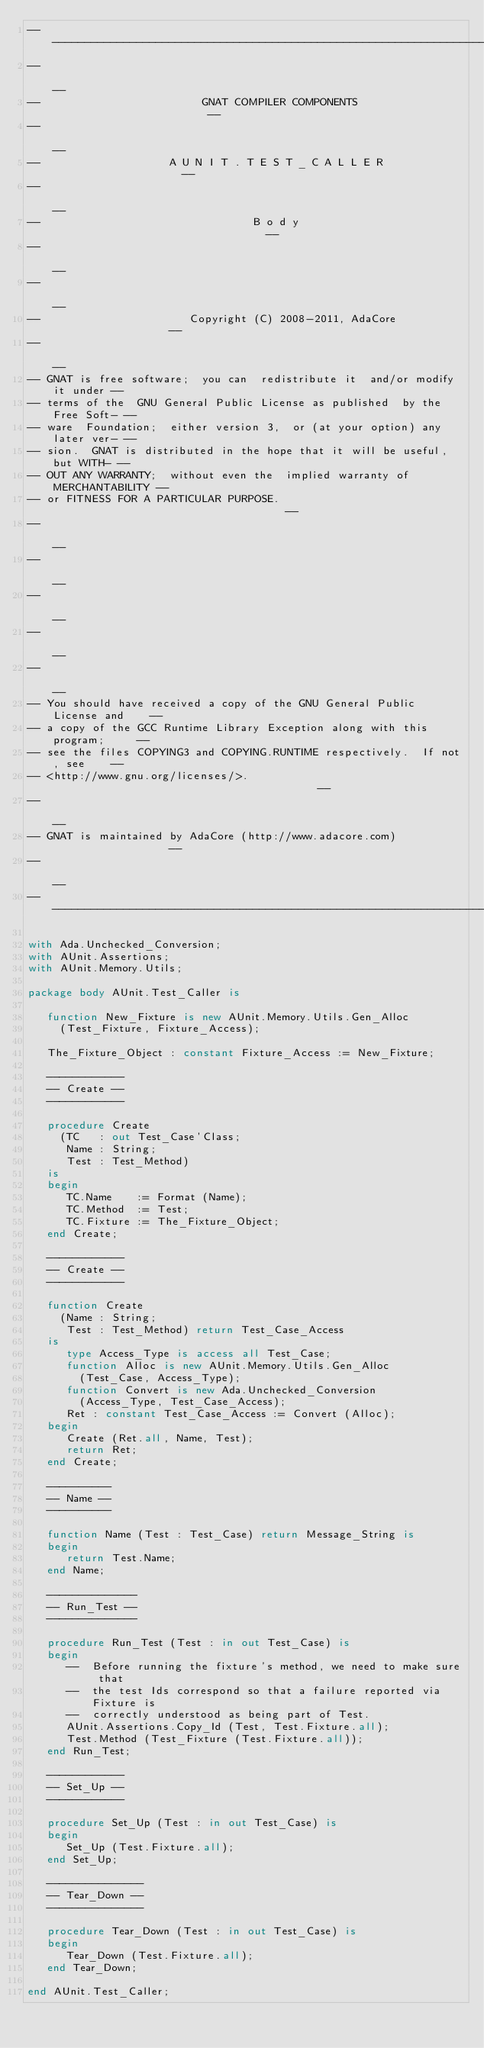Convert code to text. <code><loc_0><loc_0><loc_500><loc_500><_Ada_>------------------------------------------------------------------------------
--                                                                          --
--                         GNAT COMPILER COMPONENTS                         --
--                                                                          --
--                    A U N I T . T E S T _ C A L L E R                     --
--                                                                          --
--                                 B o d y                                  --
--                                                                          --
--                                                                          --
--                       Copyright (C) 2008-2011, AdaCore                   --
--                                                                          --
-- GNAT is free software;  you can  redistribute it  and/or modify it under --
-- terms of the  GNU General Public License as published  by the Free Soft- --
-- ware  Foundation;  either version 3,  or (at your option) any later ver- --
-- sion.  GNAT is distributed in the hope that it will be useful, but WITH- --
-- OUT ANY WARRANTY;  without even the  implied warranty of MERCHANTABILITY --
-- or FITNESS FOR A PARTICULAR PURPOSE.                                     --
--                                                                          --
--                                                                          --
--                                                                          --
--                                                                          --
--                                                                          --
-- You should have received a copy of the GNU General Public License and    --
-- a copy of the GCC Runtime Library Exception along with this program;     --
-- see the files COPYING3 and COPYING.RUNTIME respectively.  If not, see    --
-- <http://www.gnu.org/licenses/>.                                          --
--                                                                          --
-- GNAT is maintained by AdaCore (http://www.adacore.com)                   --
--                                                                          --
------------------------------------------------------------------------------

with Ada.Unchecked_Conversion;
with AUnit.Assertions;
with AUnit.Memory.Utils;

package body AUnit.Test_Caller is

   function New_Fixture is new AUnit.Memory.Utils.Gen_Alloc
     (Test_Fixture, Fixture_Access);

   The_Fixture_Object : constant Fixture_Access := New_Fixture;

   ------------
   -- Create --
   ------------

   procedure Create
     (TC   : out Test_Case'Class;
      Name : String;
      Test : Test_Method)
   is
   begin
      TC.Name    := Format (Name);
      TC.Method  := Test;
      TC.Fixture := The_Fixture_Object;
   end Create;

   ------------
   -- Create --
   ------------

   function Create
     (Name : String;
      Test : Test_Method) return Test_Case_Access
   is
      type Access_Type is access all Test_Case;
      function Alloc is new AUnit.Memory.Utils.Gen_Alloc
        (Test_Case, Access_Type);
      function Convert is new Ada.Unchecked_Conversion
        (Access_Type, Test_Case_Access);
      Ret : constant Test_Case_Access := Convert (Alloc);
   begin
      Create (Ret.all, Name, Test);
      return Ret;
   end Create;

   ----------
   -- Name --
   ----------

   function Name (Test : Test_Case) return Message_String is
   begin
      return Test.Name;
   end Name;

   --------------
   -- Run_Test --
   --------------

   procedure Run_Test (Test : in out Test_Case) is
   begin
      --  Before running the fixture's method, we need to make sure that
      --  the test Ids correspond so that a failure reported via Fixture is
      --  correctly understood as being part of Test.
      AUnit.Assertions.Copy_Id (Test, Test.Fixture.all);
      Test.Method (Test_Fixture (Test.Fixture.all));
   end Run_Test;

   ------------
   -- Set_Up --
   ------------

   procedure Set_Up (Test : in out Test_Case) is
   begin
      Set_Up (Test.Fixture.all);
   end Set_Up;

   ---------------
   -- Tear_Down --
   ---------------

   procedure Tear_Down (Test : in out Test_Case) is
   begin
      Tear_Down (Test.Fixture.all);
   end Tear_Down;

end AUnit.Test_Caller;
</code> 